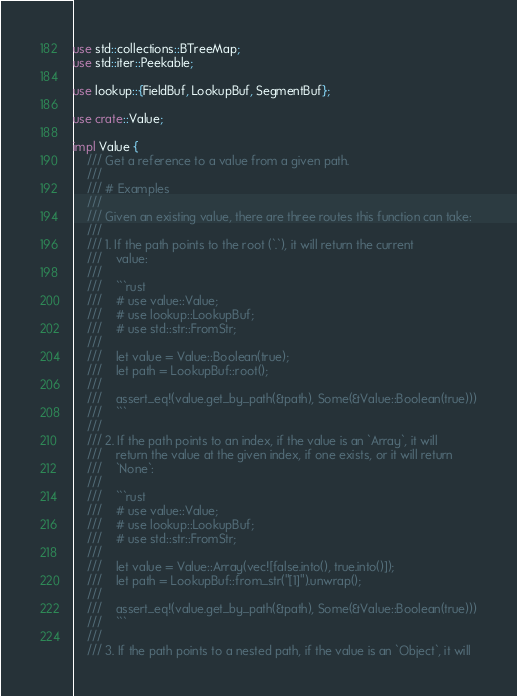<code> <loc_0><loc_0><loc_500><loc_500><_Rust_>use std::collections::BTreeMap;
use std::iter::Peekable;

use lookup::{FieldBuf, LookupBuf, SegmentBuf};

use crate::Value;

impl Value {
    /// Get a reference to a value from a given path.
    ///
    /// # Examples
    ///
    /// Given an existing value, there are three routes this function can take:
    ///
    /// 1. If the path points to the root (`.`), it will return the current
    ///    value:
    ///
    ///    ```rust
    ///    # use value::Value;
    ///    # use lookup::LookupBuf;
    ///    # use std::str::FromStr;
    ///
    ///    let value = Value::Boolean(true);
    ///    let path = LookupBuf::root();
    ///
    ///    assert_eq!(value.get_by_path(&path), Some(&Value::Boolean(true)))
    ///    ```
    ///
    /// 2. If the path points to an index, if the value is an `Array`, it will
    ///    return the value at the given index, if one exists, or it will return
    ///    `None`:
    ///
    ///    ```rust
    ///    # use value::Value;
    ///    # use lookup::LookupBuf;
    ///    # use std::str::FromStr;
    ///
    ///    let value = Value::Array(vec![false.into(), true.into()]);
    ///    let path = LookupBuf::from_str("[1]").unwrap();
    ///
    ///    assert_eq!(value.get_by_path(&path), Some(&Value::Boolean(true)))
    ///    ```
    ///
    /// 3. If the path points to a nested path, if the value is an `Object`, it will</code> 